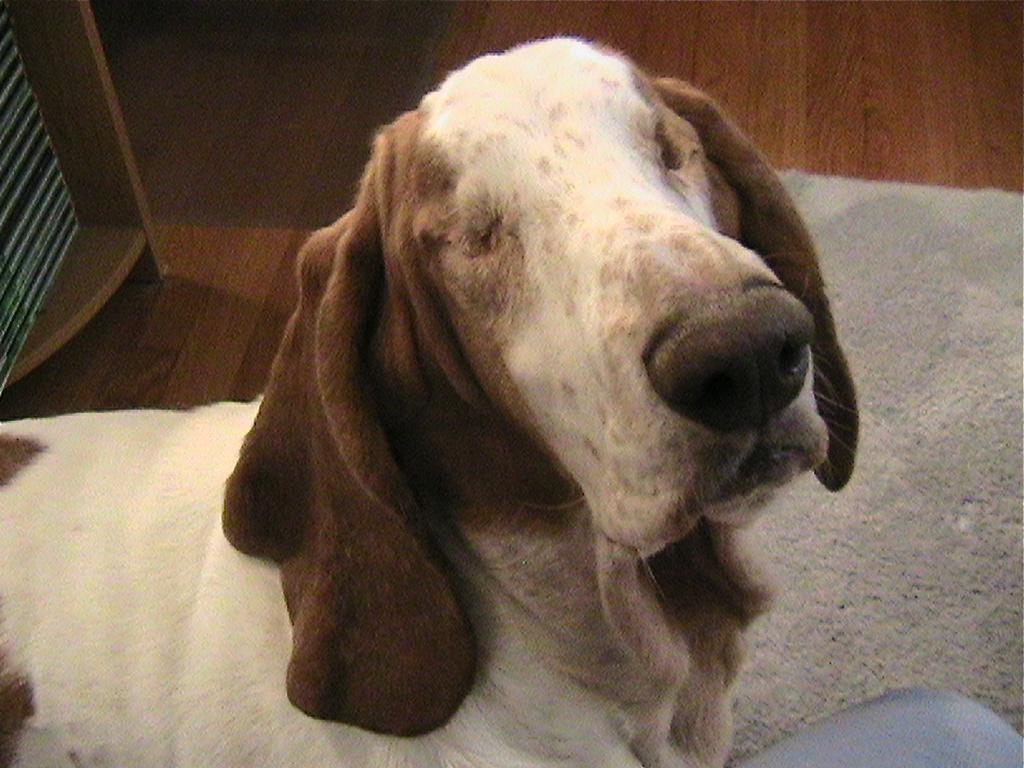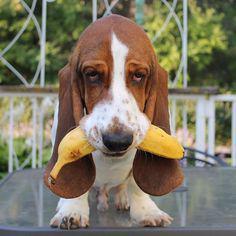The first image is the image on the left, the second image is the image on the right. Considering the images on both sides, is "One of the images shows at least one Basset Hound with something in their mouth." valid? Answer yes or no. Yes. The first image is the image on the left, the second image is the image on the right. Considering the images on both sides, is "In one of the images there is a dog eating a carrot." valid? Answer yes or no. No. 